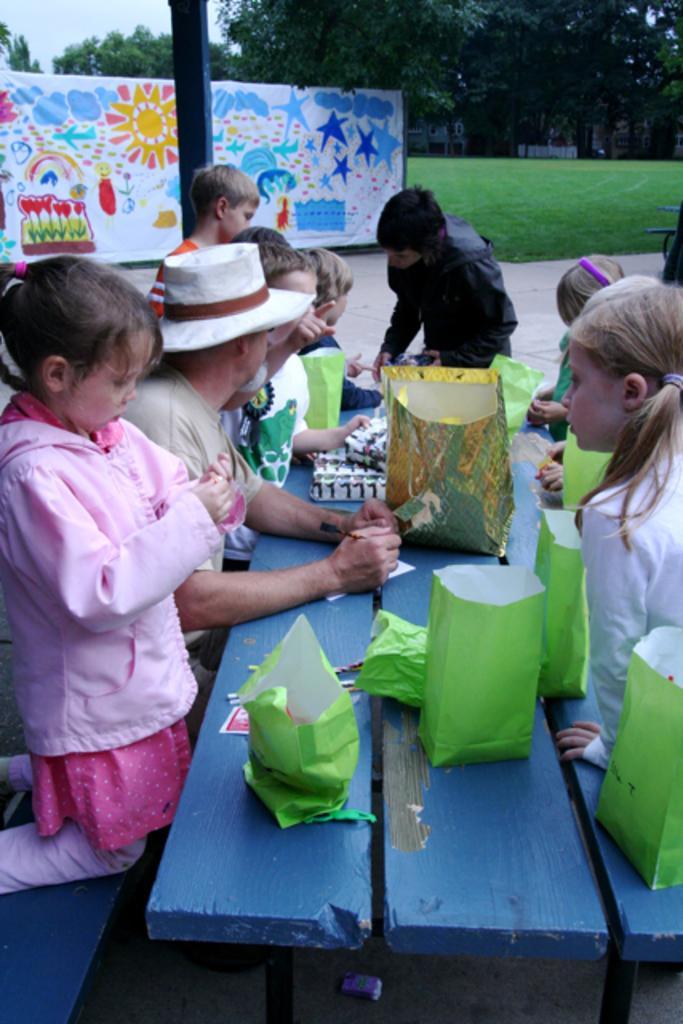How would you summarize this image in a sentence or two? In this image we can see a group of people are sitting, in front here is the table, and some objects on it, here is the grass, here are the trees, here is the banner, at above here is the sky. 